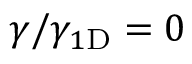<formula> <loc_0><loc_0><loc_500><loc_500>\gamma / \gamma _ { 1 { D } } = 0</formula> 